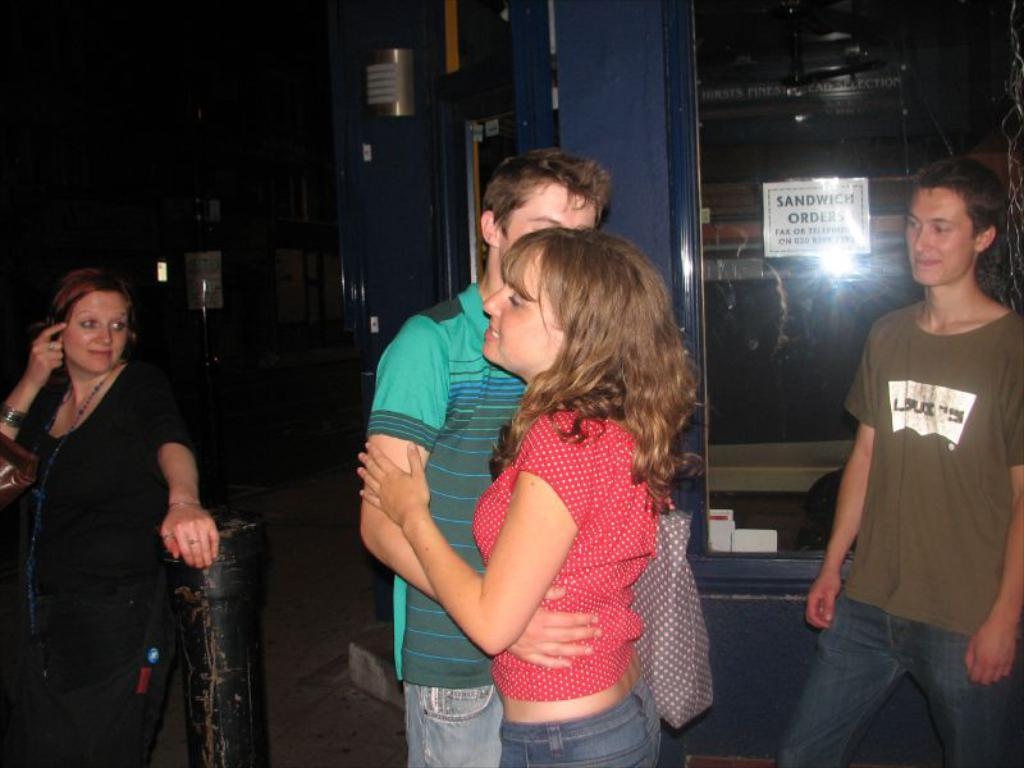How many people are present in the image? There are four people in the image. What can be seen on the ground in the image? There is a pole on the ground in the image. What is the woman in the image carrying? The woman is carrying a bag in the image. What is on the glass surface in the image? There is a poster on a glass surface in the image, and there are objects visible on the glass surface as well. How would you describe the background of the image? The background of the image is dark. How many eggs are visible on the whip in the image? There are no eggs or whip present in the image. 